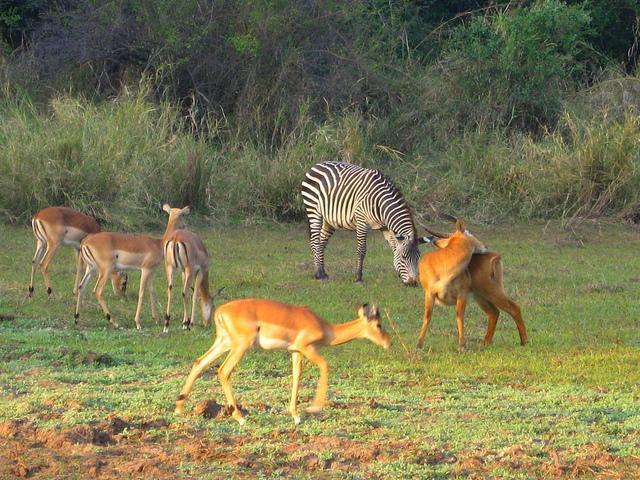How many types of animals are visible?
Give a very brief answer. 2. 